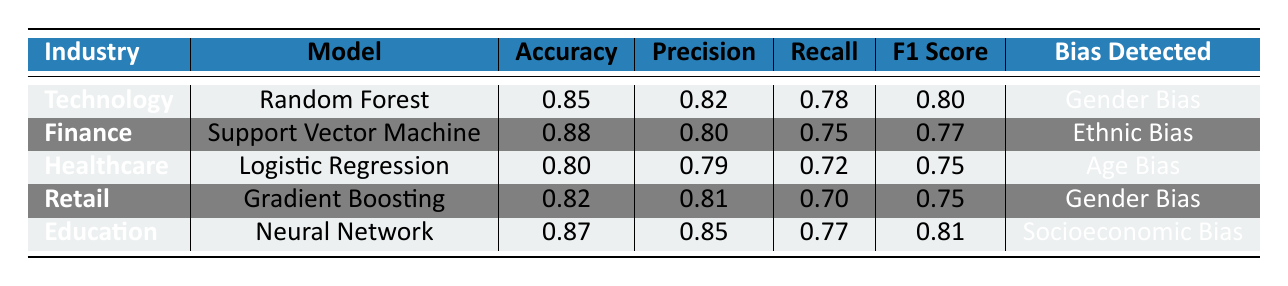What is the accuracy of the model used in the Finance industry? The value in the accuracy column for the Finance industry row is 0.88, which corresponds to the model Support Vector Machine.
Answer: 0.88 Which model has the highest precision among the industries listed? By comparing the precision values: Technology (0.82), Finance (0.80), Healthcare (0.79), Retail (0.81), and Education (0.85), Education has the highest precision at 0.85.
Answer: 0.85 Is there an industry that reports Age Bias in its hiring model? By scanning the bias detected column, it is evident that only the Healthcare industry has the bias detected as Age Bias.
Answer: Yes What is the F1 Score for the model used in the Technology industry? In the row for Technology, the F1 Score value is noted as 0.80.
Answer: 0.80 Which model has the highest accuracy, and what industry does it belong to? The accuracy values are 0.85 (Technology), 0.88 (Finance), 0.80 (Healthcare), 0.82 (Retail), and 0.87 (Education). The highest accuracy is 0.88, belonging to the Finance industry with the Support Vector Machine model.
Answer: Support Vector Machine, Finance What is the average recall of the models used in all industries? The recall values are 0.78 (Technology), 0.75 (Finance), 0.72 (Healthcare), 0.70 (Retail), and 0.77 (Education). Adding them gives a total of 3.72; dividing this by the number of industries (5) gives an average recall of 0.744.
Answer: 0.744 Is Gender Bias detected in more than one industry listed? Scanning the bias detected column reveals Gender Bias is listed for both Technology and Retail. Therefore, it is found in more than one industry.
Answer: Yes Which industry has the lowest accuracy and what is its value? Checking the accuracy values, Healthcare has the lowest accuracy of 0.80.
Answer: Healthcare, 0.80 What is the difference in F1 Score between the best and worst performing models? The best F1 Score is 0.81 (Education) and the worst is 0.75 (Healthcare). Computing the difference, 0.81 - 0.75 = 0.06.
Answer: 0.06 